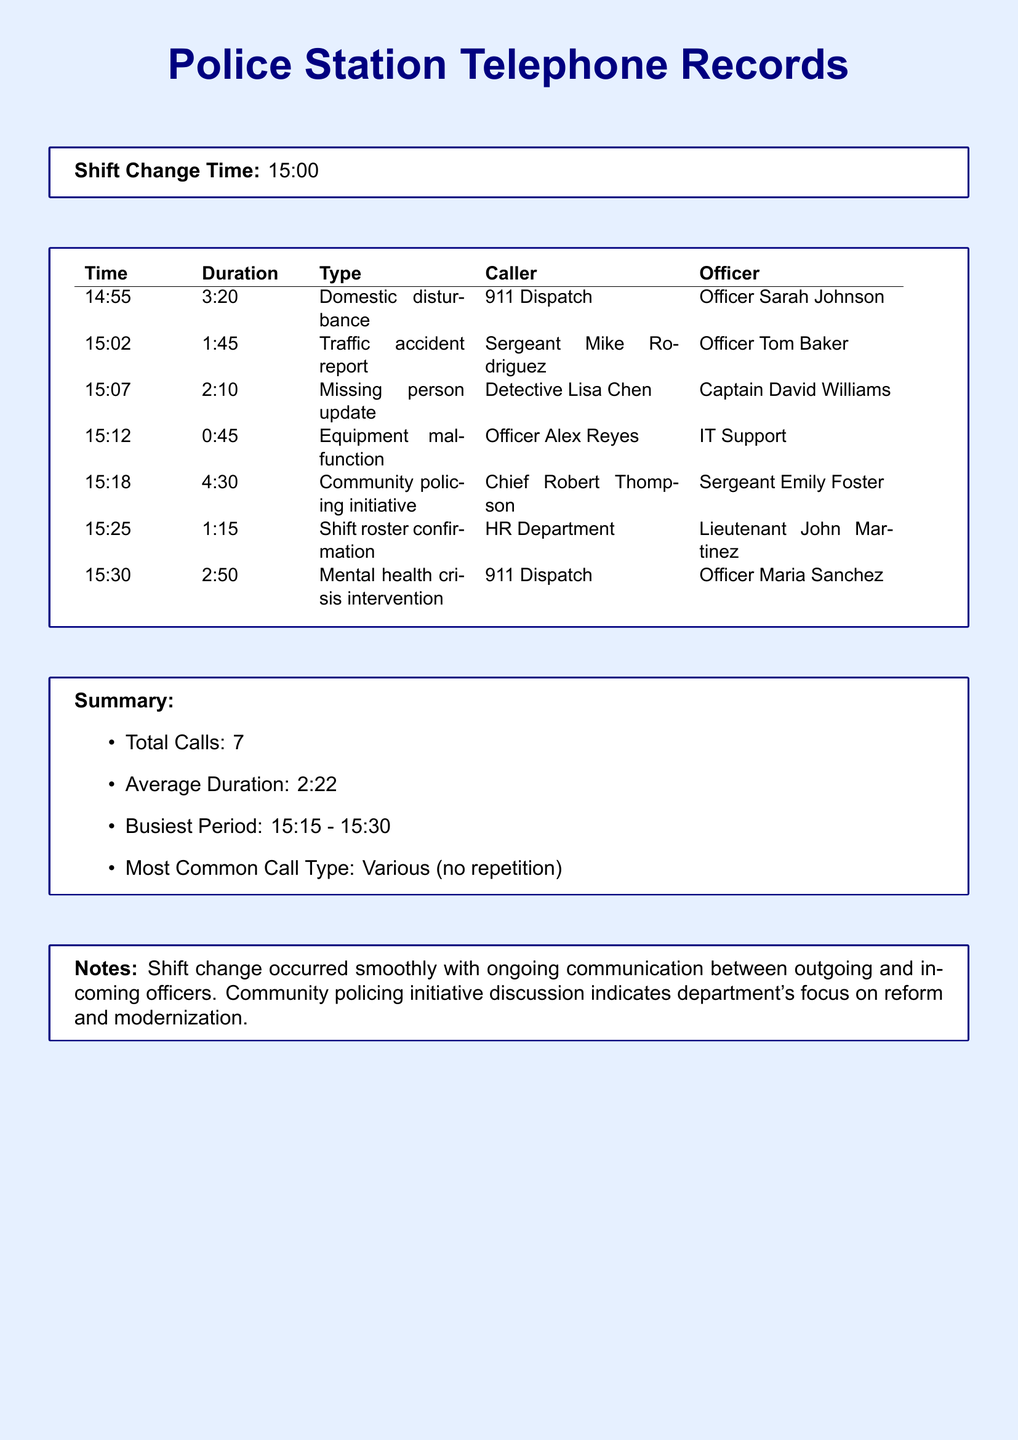what time did the shift change occur? The shift change time is explicitly stated in the document.
Answer: 15:00 who made the call about the missing person update? The caller for the missing person update is listed in the table under "Caller."
Answer: Detective Lisa Chen what was the duration of the community policing initiative call? The duration for the community policing initiative is provided in the duration column of the table.
Answer: 4:30 how many total calls were made during the shift change? The total number of calls is mentioned in the summary section of the document.
Answer: 7 which type of call was the busiest period related to? The busiest period noted corresponds to a specific time frame with various call types, requiring inference from the duration's context.
Answer: Various what is the average duration of calls? The average duration of calls is summarized in the document.
Answer: 2:22 who was the officer involved in the traffic accident report call? The officer handling the traffic accident report is listed alongside the call details in the table.
Answer: Officer Tom Baker what is noted about the department's focus? The notes section provides insight into the department’s intent as discussed during calls.
Answer: Reform and modernization 